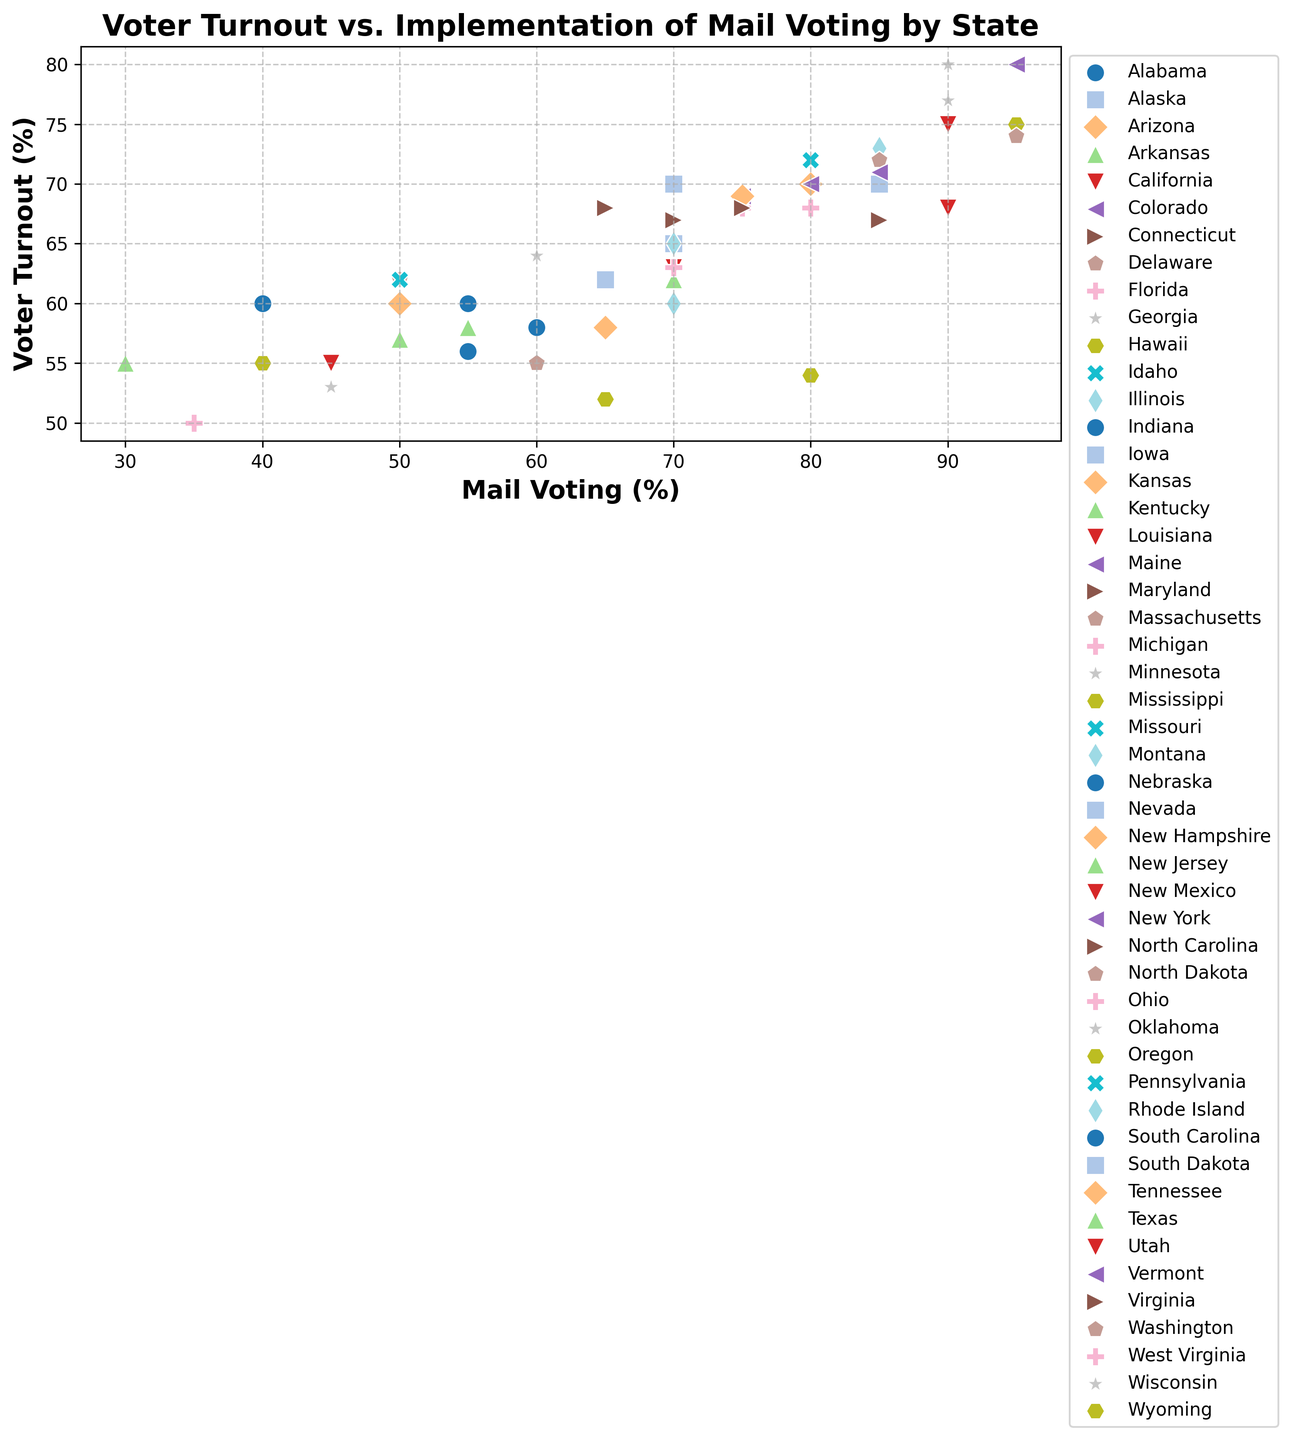What is the voter turnout for California, and how does it compare to the mail voting percentage for Texas? The scatter plot shows the voter turnout percentage on the y-axis and the mail voting percentage on the x-axis. Locate California on the plot, which has a voter turnout of 75%, and Texas with a mail voting percentage of 55%.
Answer: California's voter turnout is 75%, and Texas's mail voting percentage is 55% Which state shows the highest voter turnout, and what is its corresponding mail voting percentage? Find the point that is the highest on the y-axis. This point will indicate the state with the highest voter turnout. The state with the highest voter turnout is Colorado, with 80% voter turnout and a mail voting percentage of 95%.
Answer: Colorado has the highest voter turnout at 80%, with a mail voting percentage of 95% Identify the state that has both mail voting and voter turnout percentages above 90%. Look for points on the plot that are both to the right of the 90% mark on the x-axis and above the 90% mark on the y-axis. Minnesota and Washington meet both criteria—both have mail voting and voter turnout percentages above 90%.
Answer: Minnesota and Washington Do states with higher mail voting percentages generally have higher voter turnout? To answer this, observe the general trend of points on the scatter plot. Look for a pattern or correlation between mail voting on the x-axis and voter turnout on the y-axis. A positive correlation (upward trend) will indicate that states with higher mail voting percentages tend to have higher voter turnout.
Answer: Yes, there is a general upward trend, indicating a positive correlation What is the average voter turnout for states with mail voting percentages above 70%? Identify all the states with mail voting percentages above 70% and calculate the average of their voter turnout percentages. The states are Alaska, Arizona, California, Colorado, Connecticut, Florida, Hawaii, Illinois, Iowa, Massachusetts, Michigan, Minnesota, Nevada, New Hampshire, New Jersey, New York, Oregon, Pennsylvania, Rhode Island, Utah, Vermont, and Washington. Find their voter turnout percentages and compute the average: (65+70+75+80+67+68+54+73+70+72+68+80+70+69+62+70+75+72+65+68+71+74+77) / 23 = 69.56.
Answer: 69.56% Which state with a mail voting percentage of 55% has the highest voter turnout, and what is the turnout? Locate the points where the mail voting percentage is 55%, then find the one with the highest y-coordinate (voter turnout). Ohio has the highest voter turnout, followed by Indiana and Texas, both with the same mail voting percentage but lower voter turnout.
Answer: Ohio, with a voter turnout of 63% Does any state with a voter turnout below 60% have mail voting above 85%? Check the lower part of the plot (voter turnout < 60%) and see if any points are towards the extreme right (mail voting > 85%). Hawaii has a voter turnout below 60% (54%) and mail voting above 85% (80%).
Answer: No states have mail voting above 85% with voter turnout below 60% 